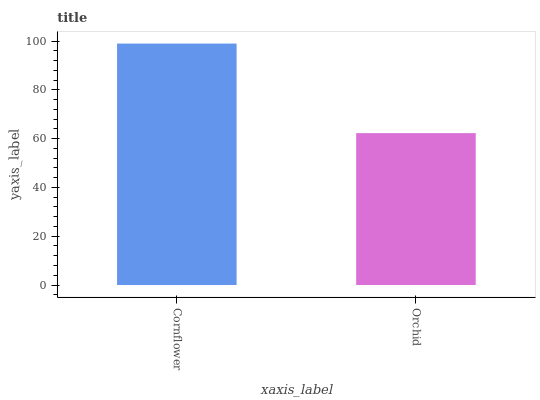Is Orchid the minimum?
Answer yes or no. Yes. Is Cornflower the maximum?
Answer yes or no. Yes. Is Orchid the maximum?
Answer yes or no. No. Is Cornflower greater than Orchid?
Answer yes or no. Yes. Is Orchid less than Cornflower?
Answer yes or no. Yes. Is Orchid greater than Cornflower?
Answer yes or no. No. Is Cornflower less than Orchid?
Answer yes or no. No. Is Cornflower the high median?
Answer yes or no. Yes. Is Orchid the low median?
Answer yes or no. Yes. Is Orchid the high median?
Answer yes or no. No. Is Cornflower the low median?
Answer yes or no. No. 